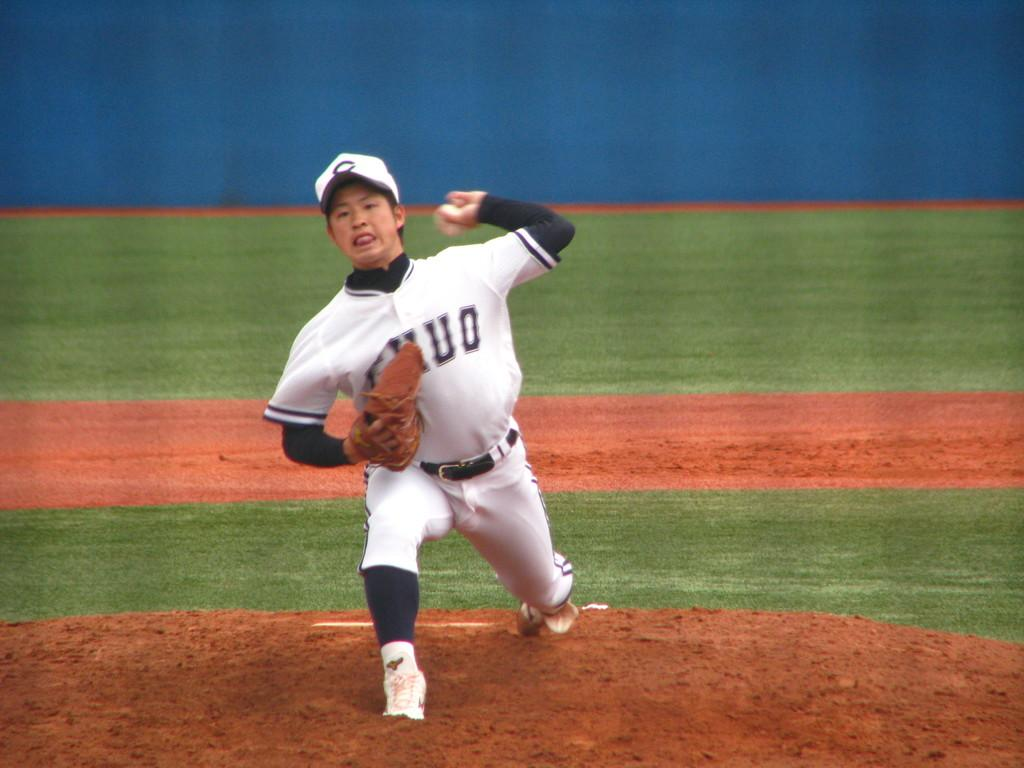What is the main subject of the image? There is a person in the image. What is the person wearing on their hand? The person is wearing a glove. What action is the person performing in the image? The person is throwing a ball with their hand. What type of clothing is the person wearing? The person is wearing clothes. What type of headwear is the person wearing? The person is wearing a cap. What type of sponge is being used to develop the image? There is no sponge or development process involved in the image; it is a photograph of a person. What type of oven is visible in the image? There is no oven present in the image. 